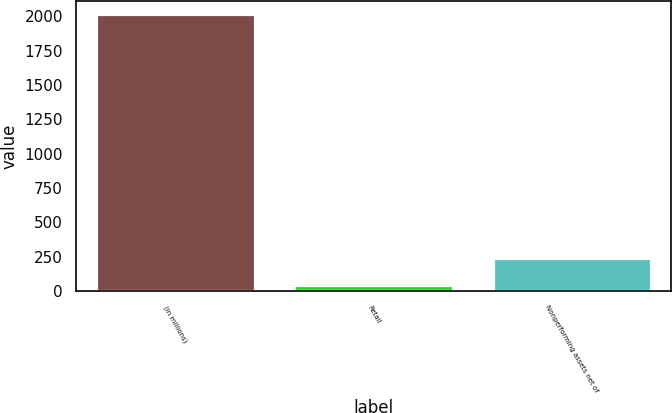Convert chart. <chart><loc_0><loc_0><loc_500><loc_500><bar_chart><fcel>(in millions)<fcel>Retail<fcel>Nonperforming assets net of<nl><fcel>2015<fcel>45<fcel>242<nl></chart> 